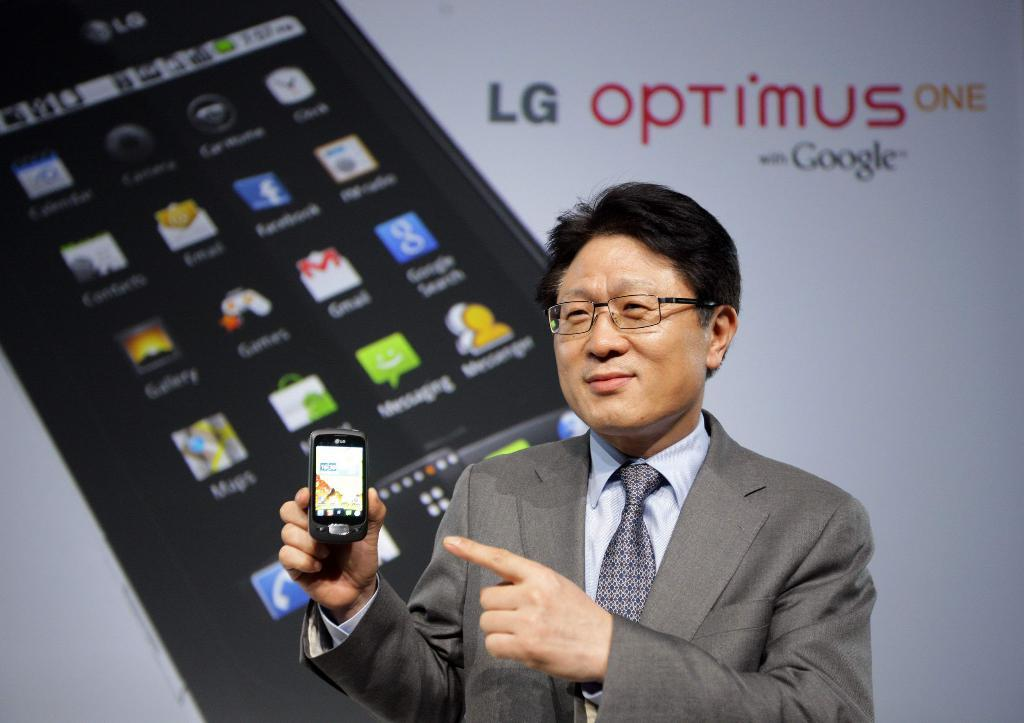<image>
Offer a succinct explanation of the picture presented. an LG optimus sign that is behind a man 